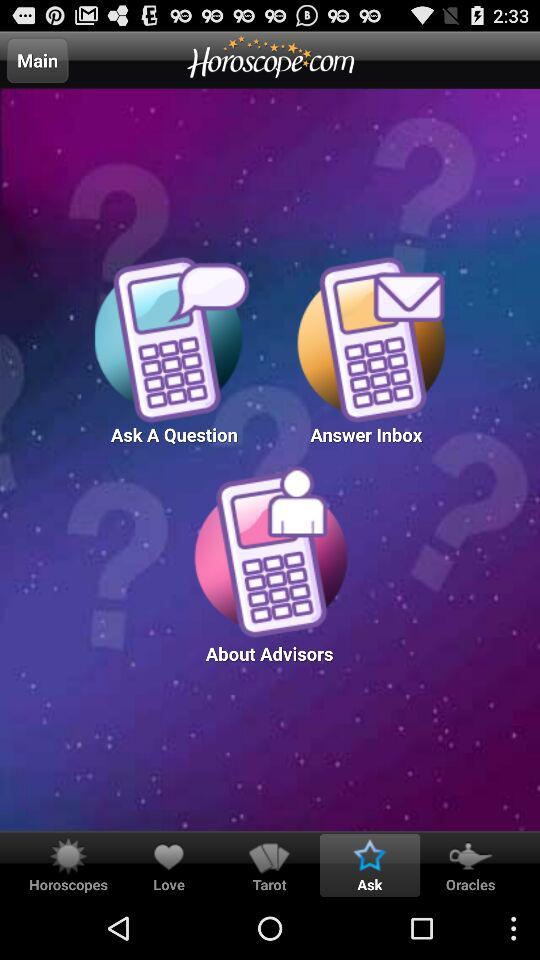What is the name of the application? The name of the application is "Horoscope.com". 